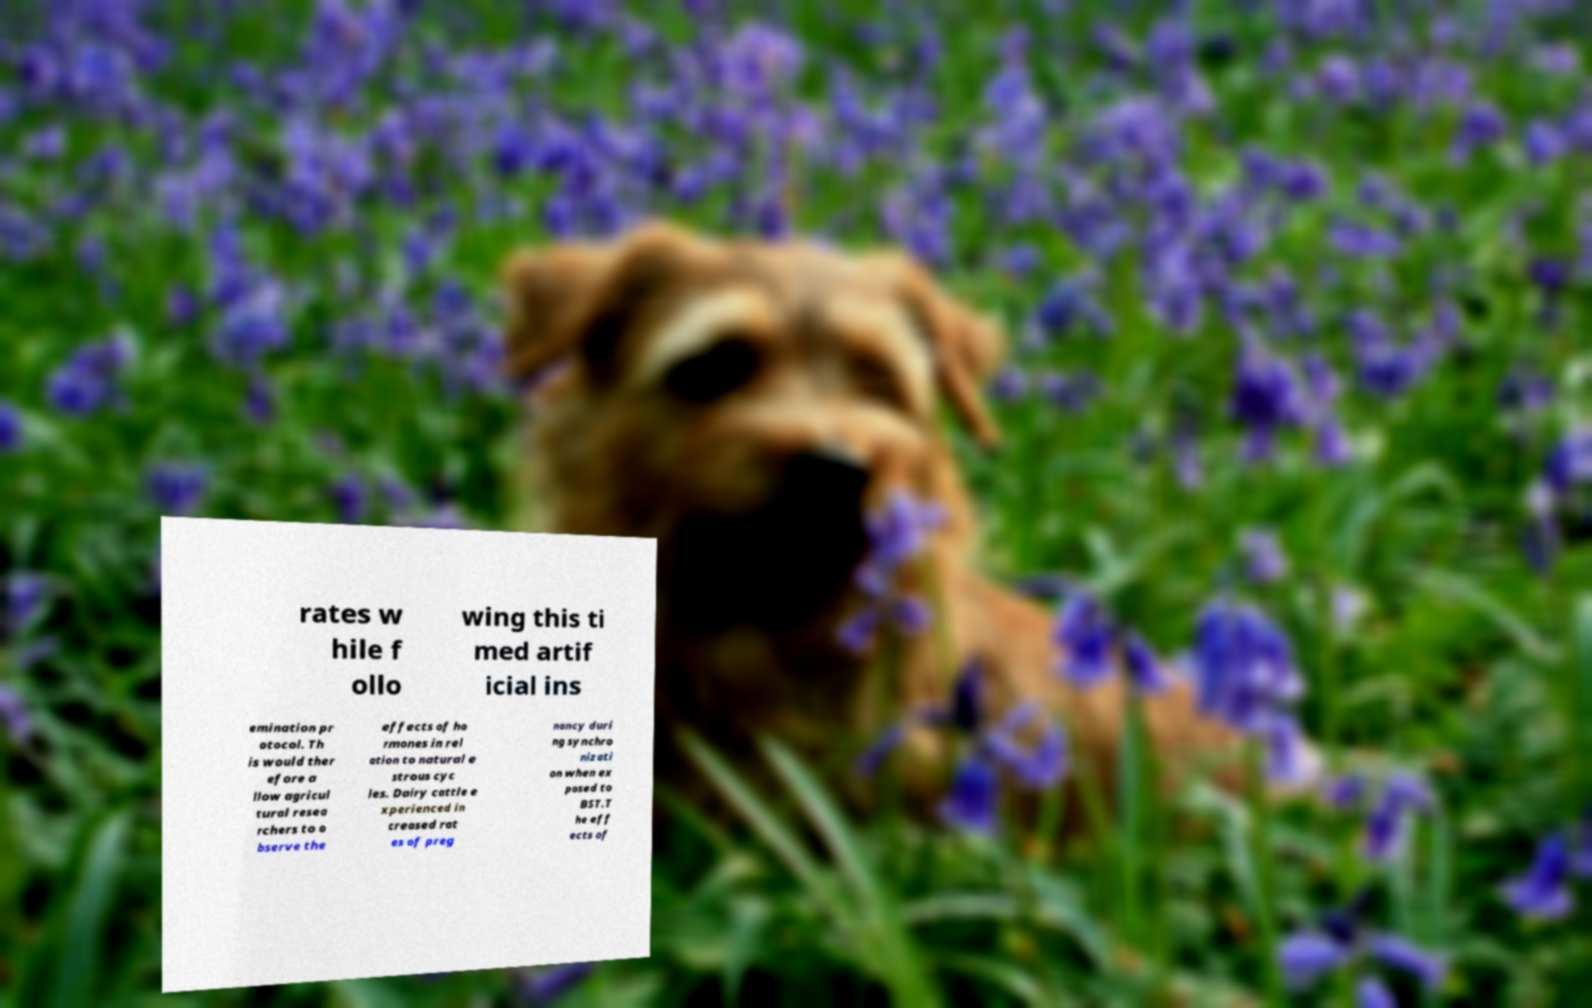Please identify and transcribe the text found in this image. rates w hile f ollo wing this ti med artif icial ins emination pr otocol. Th is would ther efore a llow agricul tural resea rchers to o bserve the effects of ho rmones in rel ation to natural e strous cyc les. Dairy cattle e xperienced in creased rat es of preg nancy duri ng synchro nizati on when ex posed to BST.T he eff ects of 